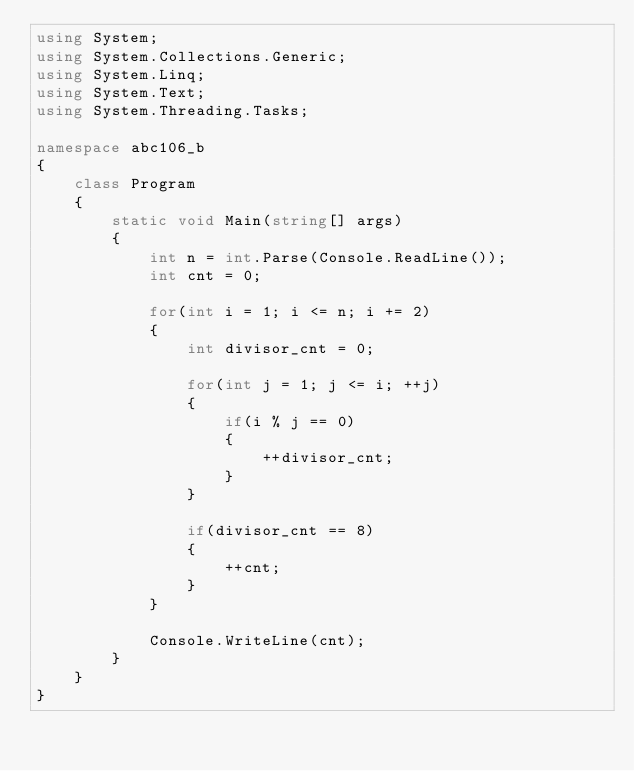<code> <loc_0><loc_0><loc_500><loc_500><_C#_>using System;
using System.Collections.Generic;
using System.Linq;
using System.Text;
using System.Threading.Tasks;

namespace abc106_b
{
    class Program
    {
        static void Main(string[] args)
        {
            int n = int.Parse(Console.ReadLine());
            int cnt = 0;

            for(int i = 1; i <= n; i += 2)
            {
                int divisor_cnt = 0;

                for(int j = 1; j <= i; ++j)
                {
                    if(i % j == 0)
                    {
                        ++divisor_cnt;
                    }
                }

                if(divisor_cnt == 8)
                {
                    ++cnt;
                }
            }

            Console.WriteLine(cnt);
        }
    }
}
</code> 